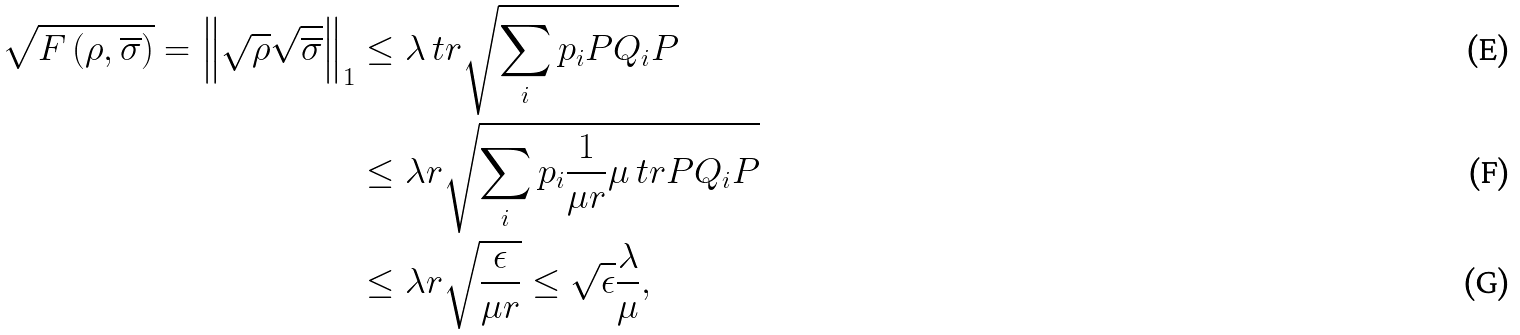<formula> <loc_0><loc_0><loc_500><loc_500>\sqrt { F \left ( \rho , \overline { \sigma } \right ) } = \left \| \sqrt { \rho } \sqrt { \overline { \sigma } } \right \| _ { 1 } & \leq \lambda \ t r \sqrt { \sum _ { i } p _ { i } P Q _ { i } P } \\ & \leq \lambda r \sqrt { \sum _ { i } p _ { i } \frac { 1 } { \mu r } \mu \ t r P Q _ { i } P } \\ & \leq \lambda r \sqrt { \frac { \epsilon } { \mu r } } \leq \sqrt { \epsilon } \frac { \lambda } { \mu } ,</formula> 